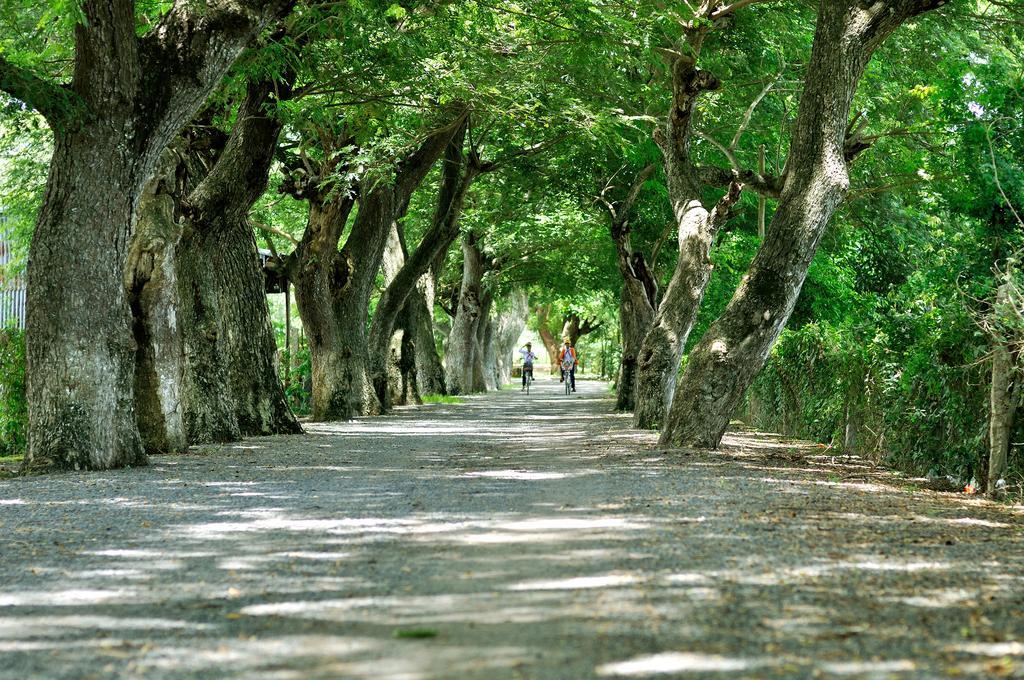Describe this image in one or two sentences. In this picture we can see two people are riding on the bicycles. We can see a few trees on both sides of the path. 